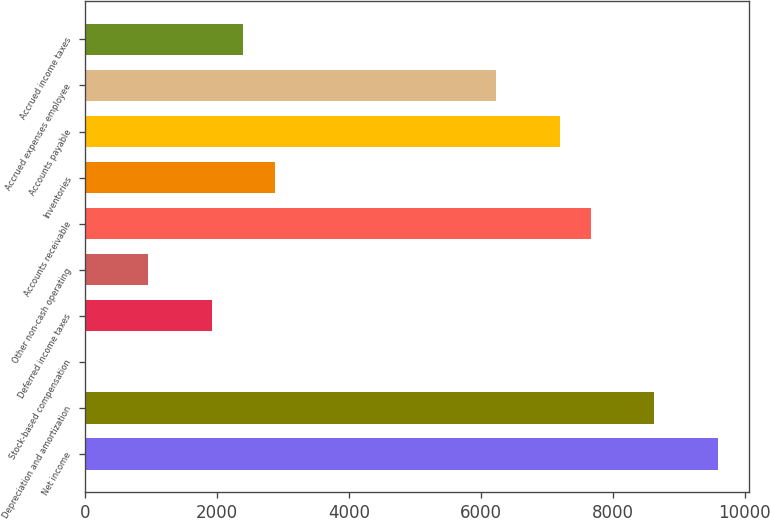<chart> <loc_0><loc_0><loc_500><loc_500><bar_chart><fcel>Net income<fcel>Depreciation and amortization<fcel>Stock-based compensation<fcel>Deferred income taxes<fcel>Other non-cash operating<fcel>Accounts receivable<fcel>Inventories<fcel>Accounts payable<fcel>Accrued expenses employee<fcel>Accrued income taxes<nl><fcel>9590<fcel>8631.2<fcel>2<fcel>1919.6<fcel>960.8<fcel>7672.4<fcel>2878.4<fcel>7193<fcel>6234.2<fcel>2399<nl></chart> 